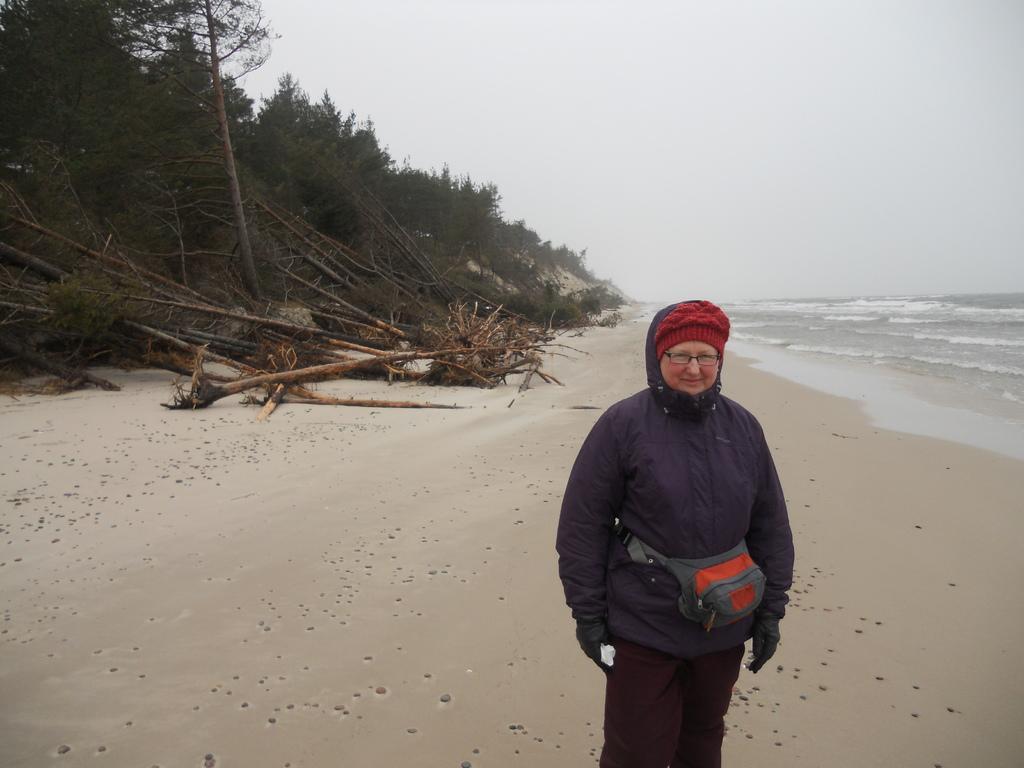Describe this image in one or two sentences. In this picture we can see a person is standing on the path and behind the person there are trees, sea and a sky. 